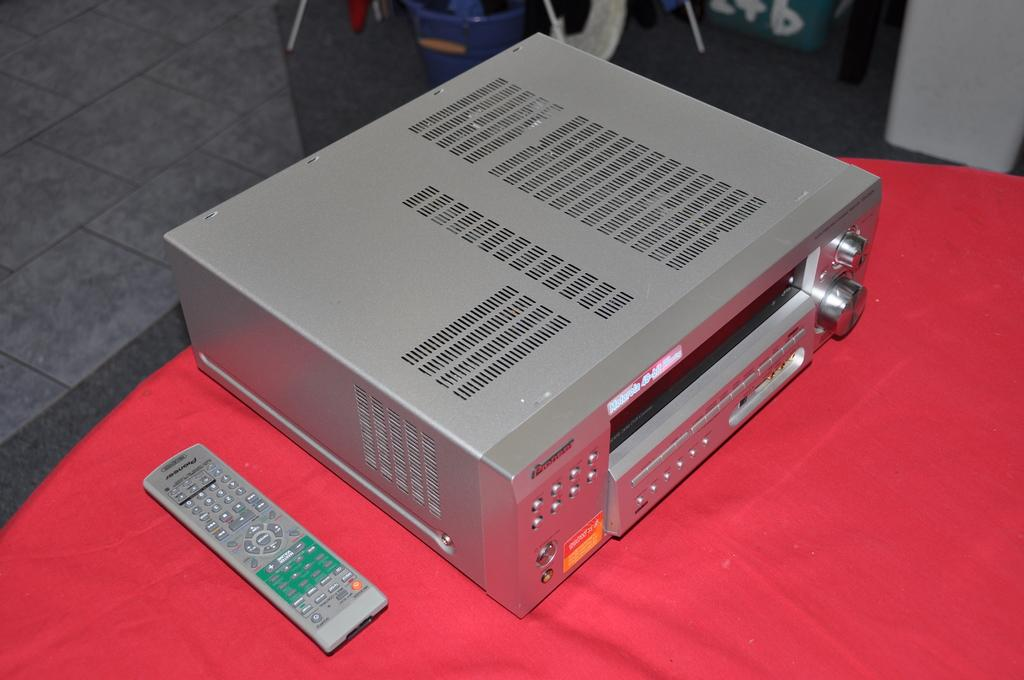<image>
Render a clear and concise summary of the photo. A gray appliance and a gray pioneer remote on the table. 